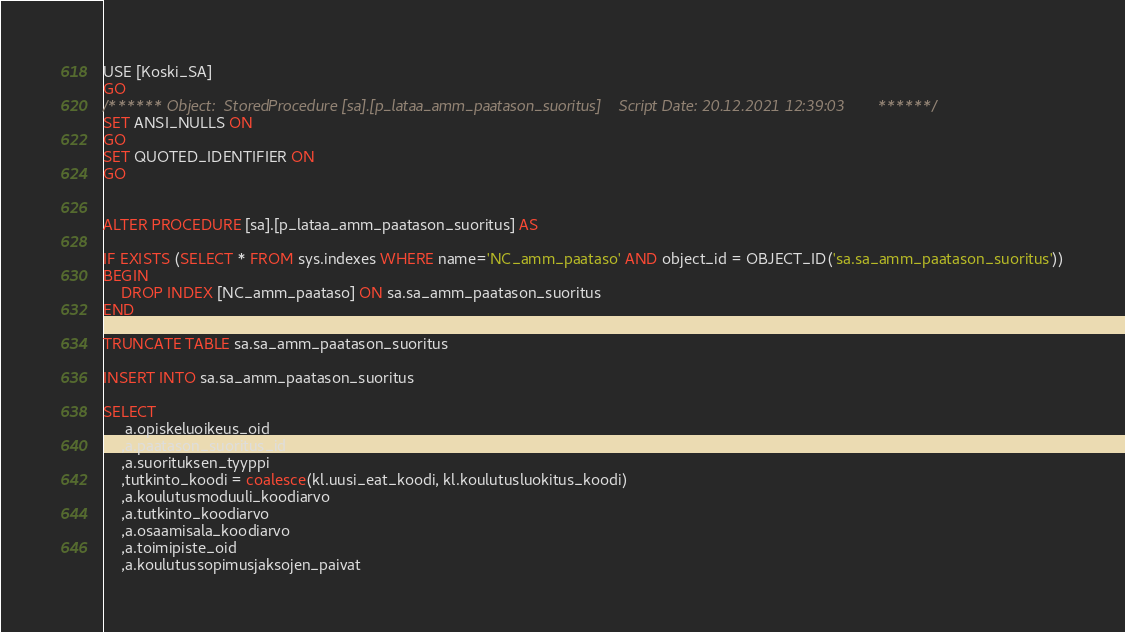Convert code to text. <code><loc_0><loc_0><loc_500><loc_500><_SQL_>USE [Koski_SA]
GO
/****** Object:  StoredProcedure [sa].[p_lataa_amm_paatason_suoritus]    Script Date: 20.12.2021 12:39:03 ******/
SET ANSI_NULLS ON
GO
SET QUOTED_IDENTIFIER ON
GO


ALTER PROCEDURE [sa].[p_lataa_amm_paatason_suoritus] AS

IF EXISTS (SELECT * FROM sys.indexes WHERE name='NC_amm_paataso' AND object_id = OBJECT_ID('sa.sa_amm_paatason_suoritus'))
BEGIN
	DROP INDEX [NC_amm_paataso] ON sa.sa_amm_paatason_suoritus
END

TRUNCATE TABLE sa.sa_amm_paatason_suoritus

INSERT INTO sa.sa_amm_paatason_suoritus

SELECT 
	 a.opiskeluoikeus_oid
	,a.paatason_suoritus_id
	,a.suorituksen_tyyppi
	,tutkinto_koodi = coalesce(kl.uusi_eat_koodi, kl.koulutusluokitus_koodi)
	,a.koulutusmoduuli_koodiarvo 
	,a.tutkinto_koodiarvo
	,a.osaamisala_koodiarvo
	,a.toimipiste_oid
	,a.koulutussopimusjaksojen_paivat</code> 